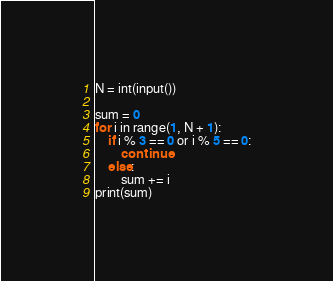<code> <loc_0><loc_0><loc_500><loc_500><_Python_>N = int(input())

sum = 0
for i in range(1, N + 1):
    if i % 3 == 0 or i % 5 == 0:
        continue
    else:
        sum += i
print(sum)
</code> 